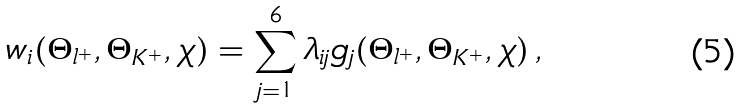Convert formula to latex. <formula><loc_0><loc_0><loc_500><loc_500>w _ { i } ( \Theta _ { l ^ { + } } , \Theta _ { K ^ { + } } , \chi ) = \sum _ { j = 1 } ^ { 6 } \lambda _ { i j } g _ { j } ( \Theta _ { l ^ { + } } , \Theta _ { K ^ { + } } , \chi ) \, ,</formula> 